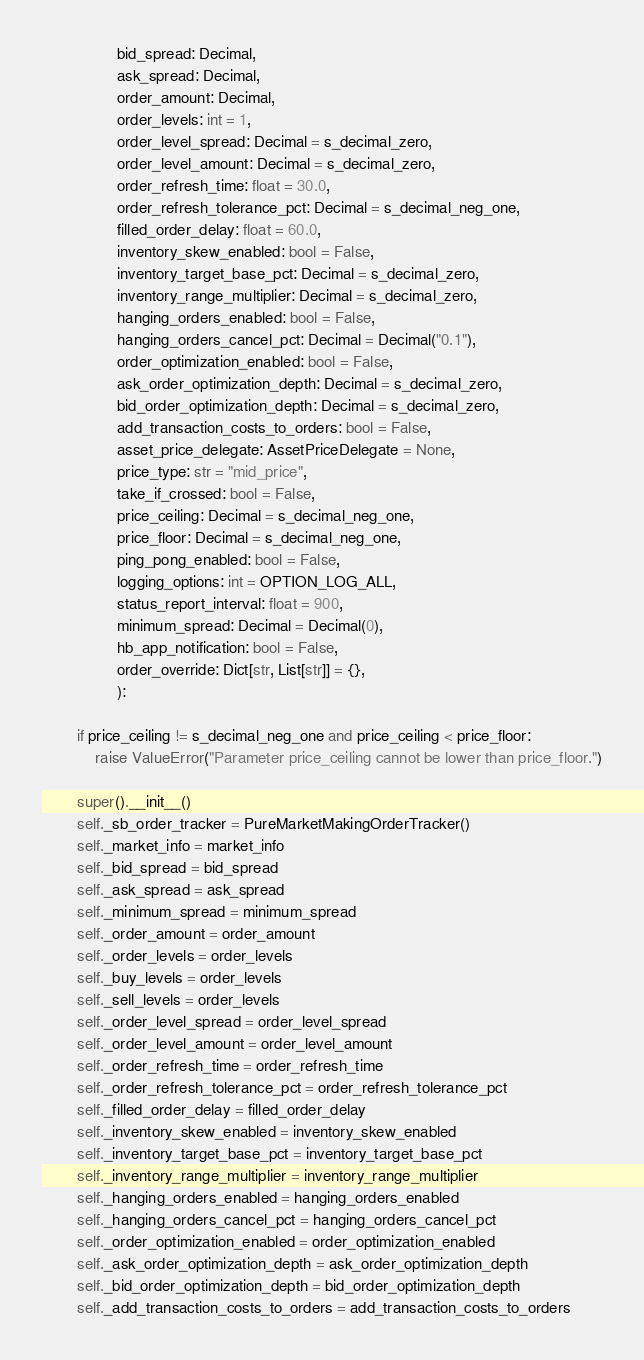<code> <loc_0><loc_0><loc_500><loc_500><_Cython_>                 bid_spread: Decimal,
                 ask_spread: Decimal,
                 order_amount: Decimal,
                 order_levels: int = 1,
                 order_level_spread: Decimal = s_decimal_zero,
                 order_level_amount: Decimal = s_decimal_zero,
                 order_refresh_time: float = 30.0,
                 order_refresh_tolerance_pct: Decimal = s_decimal_neg_one,
                 filled_order_delay: float = 60.0,
                 inventory_skew_enabled: bool = False,
                 inventory_target_base_pct: Decimal = s_decimal_zero,
                 inventory_range_multiplier: Decimal = s_decimal_zero,
                 hanging_orders_enabled: bool = False,
                 hanging_orders_cancel_pct: Decimal = Decimal("0.1"),
                 order_optimization_enabled: bool = False,
                 ask_order_optimization_depth: Decimal = s_decimal_zero,
                 bid_order_optimization_depth: Decimal = s_decimal_zero,
                 add_transaction_costs_to_orders: bool = False,
                 asset_price_delegate: AssetPriceDelegate = None,
                 price_type: str = "mid_price",
                 take_if_crossed: bool = False,
                 price_ceiling: Decimal = s_decimal_neg_one,
                 price_floor: Decimal = s_decimal_neg_one,
                 ping_pong_enabled: bool = False,
                 logging_options: int = OPTION_LOG_ALL,
                 status_report_interval: float = 900,
                 minimum_spread: Decimal = Decimal(0),
                 hb_app_notification: bool = False,
                 order_override: Dict[str, List[str]] = {},
                 ):

        if price_ceiling != s_decimal_neg_one and price_ceiling < price_floor:
            raise ValueError("Parameter price_ceiling cannot be lower than price_floor.")

        super().__init__()
        self._sb_order_tracker = PureMarketMakingOrderTracker()
        self._market_info = market_info
        self._bid_spread = bid_spread
        self._ask_spread = ask_spread
        self._minimum_spread = minimum_spread
        self._order_amount = order_amount
        self._order_levels = order_levels
        self._buy_levels = order_levels
        self._sell_levels = order_levels
        self._order_level_spread = order_level_spread
        self._order_level_amount = order_level_amount
        self._order_refresh_time = order_refresh_time
        self._order_refresh_tolerance_pct = order_refresh_tolerance_pct
        self._filled_order_delay = filled_order_delay
        self._inventory_skew_enabled = inventory_skew_enabled
        self._inventory_target_base_pct = inventory_target_base_pct
        self._inventory_range_multiplier = inventory_range_multiplier
        self._hanging_orders_enabled = hanging_orders_enabled
        self._hanging_orders_cancel_pct = hanging_orders_cancel_pct
        self._order_optimization_enabled = order_optimization_enabled
        self._ask_order_optimization_depth = ask_order_optimization_depth
        self._bid_order_optimization_depth = bid_order_optimization_depth
        self._add_transaction_costs_to_orders = add_transaction_costs_to_orders</code> 